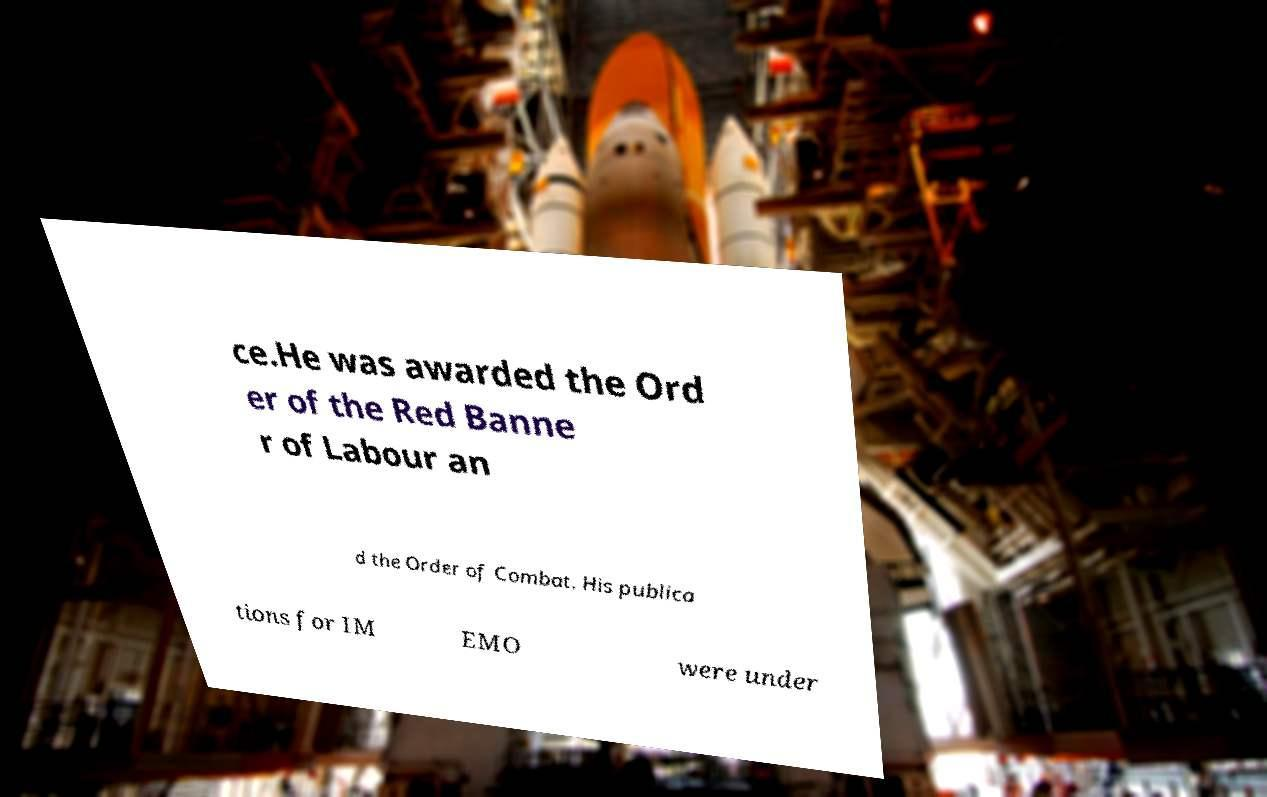For documentation purposes, I need the text within this image transcribed. Could you provide that? ce.He was awarded the Ord er of the Red Banne r of Labour an d the Order of Combat. His publica tions for IM EMO were under 